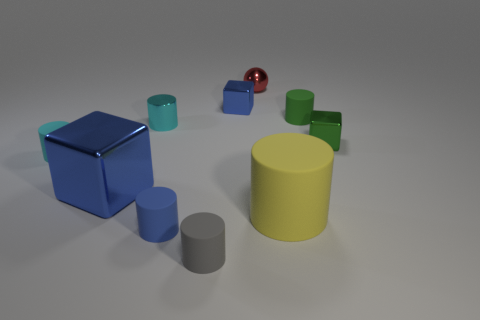Subtract all yellow cylinders. How many cylinders are left? 5 Subtract all small cyan cylinders. How many cylinders are left? 4 Subtract 3 cylinders. How many cylinders are left? 3 Subtract all red cylinders. Subtract all purple spheres. How many cylinders are left? 6 Subtract all balls. How many objects are left? 9 Subtract all large yellow shiny cylinders. Subtract all tiny red metal things. How many objects are left? 9 Add 4 blue things. How many blue things are left? 7 Add 4 blue objects. How many blue objects exist? 7 Subtract 0 brown cylinders. How many objects are left? 10 